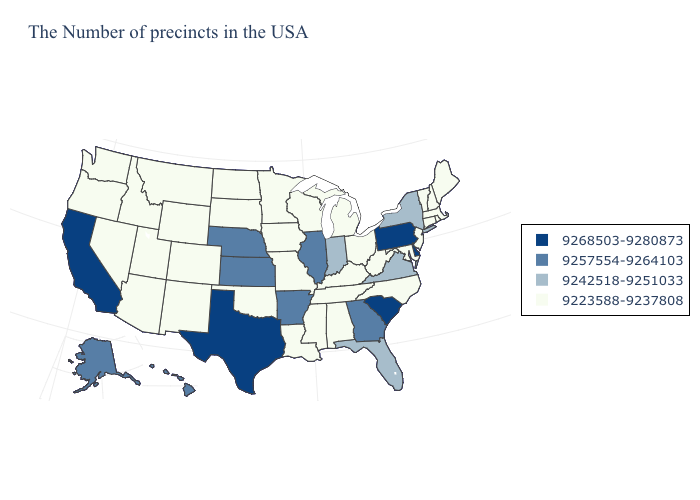Does North Carolina have the lowest value in the South?
Give a very brief answer. Yes. Does Rhode Island have a higher value than Minnesota?
Concise answer only. No. Does Arkansas have a lower value than Indiana?
Be succinct. No. Which states have the highest value in the USA?
Short answer required. Delaware, Pennsylvania, South Carolina, Texas, California. Does Pennsylvania have the same value as Virginia?
Keep it brief. No. Which states hav the highest value in the South?
Be succinct. Delaware, South Carolina, Texas. Name the states that have a value in the range 9268503-9280873?
Be succinct. Delaware, Pennsylvania, South Carolina, Texas, California. Does Ohio have a higher value than California?
Write a very short answer. No. Which states have the lowest value in the USA?
Short answer required. Maine, Massachusetts, Rhode Island, New Hampshire, Vermont, Connecticut, New Jersey, Maryland, North Carolina, West Virginia, Ohio, Michigan, Kentucky, Alabama, Tennessee, Wisconsin, Mississippi, Louisiana, Missouri, Minnesota, Iowa, Oklahoma, South Dakota, North Dakota, Wyoming, Colorado, New Mexico, Utah, Montana, Arizona, Idaho, Nevada, Washington, Oregon. Does Illinois have the highest value in the MidWest?
Give a very brief answer. Yes. Does Pennsylvania have the same value as Alabama?
Write a very short answer. No. What is the highest value in the West ?
Be succinct. 9268503-9280873. Which states hav the highest value in the West?
Keep it brief. California. Name the states that have a value in the range 9242518-9251033?
Keep it brief. New York, Virginia, Florida, Indiana. Among the states that border Massachusetts , which have the highest value?
Keep it brief. New York. 